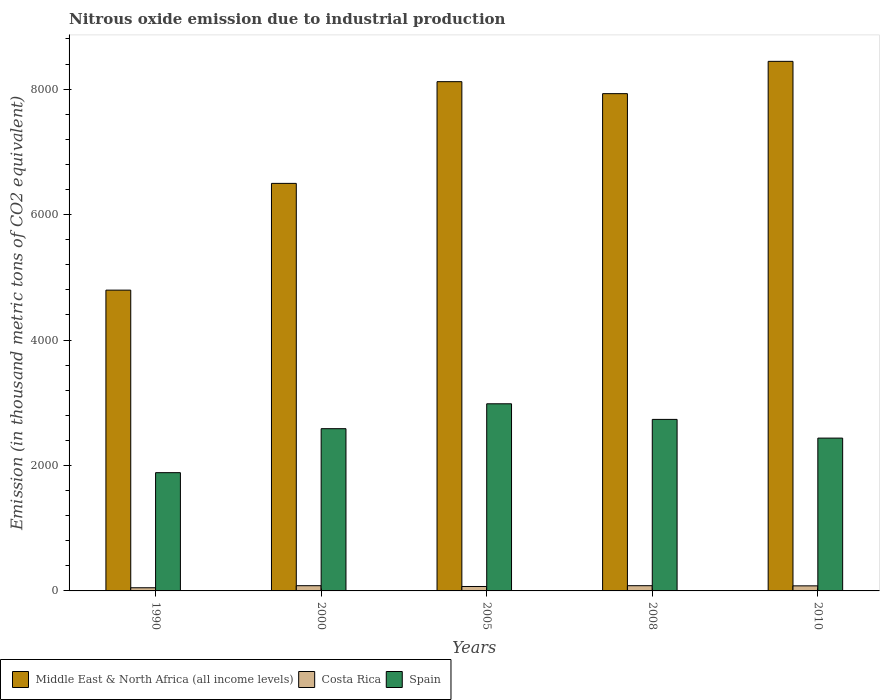How many groups of bars are there?
Your answer should be very brief. 5. Are the number of bars per tick equal to the number of legend labels?
Ensure brevity in your answer.  Yes. Are the number of bars on each tick of the X-axis equal?
Make the answer very short. Yes. How many bars are there on the 3rd tick from the right?
Provide a succinct answer. 3. What is the label of the 1st group of bars from the left?
Keep it short and to the point. 1990. In how many cases, is the number of bars for a given year not equal to the number of legend labels?
Offer a very short reply. 0. What is the amount of nitrous oxide emitted in Middle East & North Africa (all income levels) in 2010?
Your answer should be compact. 8442.5. Across all years, what is the maximum amount of nitrous oxide emitted in Costa Rica?
Your answer should be compact. 83.4. Across all years, what is the minimum amount of nitrous oxide emitted in Costa Rica?
Your answer should be compact. 50.5. In which year was the amount of nitrous oxide emitted in Spain maximum?
Make the answer very short. 2005. What is the total amount of nitrous oxide emitted in Middle East & North Africa (all income levels) in the graph?
Make the answer very short. 3.58e+04. What is the difference between the amount of nitrous oxide emitted in Costa Rica in 2000 and that in 2008?
Offer a terse response. 0. What is the difference between the amount of nitrous oxide emitted in Spain in 2010 and the amount of nitrous oxide emitted in Middle East & North Africa (all income levels) in 1990?
Your answer should be very brief. -2358.8. What is the average amount of nitrous oxide emitted in Middle East & North Africa (all income levels) per year?
Provide a succinct answer. 7156.2. In the year 2010, what is the difference between the amount of nitrous oxide emitted in Spain and amount of nitrous oxide emitted in Costa Rica?
Your answer should be very brief. 2355.6. In how many years, is the amount of nitrous oxide emitted in Middle East & North Africa (all income levels) greater than 4800 thousand metric tons?
Make the answer very short. 4. What is the ratio of the amount of nitrous oxide emitted in Spain in 2000 to that in 2010?
Offer a very short reply. 1.06. Is the difference between the amount of nitrous oxide emitted in Spain in 2000 and 2005 greater than the difference between the amount of nitrous oxide emitted in Costa Rica in 2000 and 2005?
Provide a short and direct response. No. What is the difference between the highest and the lowest amount of nitrous oxide emitted in Spain?
Offer a very short reply. 1098.1. In how many years, is the amount of nitrous oxide emitted in Spain greater than the average amount of nitrous oxide emitted in Spain taken over all years?
Provide a short and direct response. 3. What does the 2nd bar from the left in 2005 represents?
Provide a short and direct response. Costa Rica. What does the 1st bar from the right in 2010 represents?
Offer a very short reply. Spain. How many bars are there?
Your answer should be compact. 15. How many years are there in the graph?
Your answer should be very brief. 5. What is the difference between two consecutive major ticks on the Y-axis?
Offer a terse response. 2000. Does the graph contain grids?
Provide a short and direct response. No. How many legend labels are there?
Your response must be concise. 3. What is the title of the graph?
Ensure brevity in your answer.  Nitrous oxide emission due to industrial production. What is the label or title of the Y-axis?
Offer a terse response. Emission (in thousand metric tons of CO2 equivalent). What is the Emission (in thousand metric tons of CO2 equivalent) of Middle East & North Africa (all income levels) in 1990?
Your answer should be compact. 4795.2. What is the Emission (in thousand metric tons of CO2 equivalent) of Costa Rica in 1990?
Offer a terse response. 50.5. What is the Emission (in thousand metric tons of CO2 equivalent) in Spain in 1990?
Offer a terse response. 1885.3. What is the Emission (in thousand metric tons of CO2 equivalent) in Middle East & North Africa (all income levels) in 2000?
Offer a terse response. 6497. What is the Emission (in thousand metric tons of CO2 equivalent) in Costa Rica in 2000?
Offer a terse response. 83.4. What is the Emission (in thousand metric tons of CO2 equivalent) in Spain in 2000?
Your answer should be very brief. 2586.5. What is the Emission (in thousand metric tons of CO2 equivalent) of Middle East & North Africa (all income levels) in 2005?
Keep it short and to the point. 8118.6. What is the Emission (in thousand metric tons of CO2 equivalent) in Costa Rica in 2005?
Offer a very short reply. 70.7. What is the Emission (in thousand metric tons of CO2 equivalent) of Spain in 2005?
Offer a terse response. 2983.4. What is the Emission (in thousand metric tons of CO2 equivalent) in Middle East & North Africa (all income levels) in 2008?
Ensure brevity in your answer.  7927.7. What is the Emission (in thousand metric tons of CO2 equivalent) in Costa Rica in 2008?
Provide a short and direct response. 83.4. What is the Emission (in thousand metric tons of CO2 equivalent) in Spain in 2008?
Offer a very short reply. 2734.4. What is the Emission (in thousand metric tons of CO2 equivalent) of Middle East & North Africa (all income levels) in 2010?
Make the answer very short. 8442.5. What is the Emission (in thousand metric tons of CO2 equivalent) in Costa Rica in 2010?
Make the answer very short. 80.8. What is the Emission (in thousand metric tons of CO2 equivalent) in Spain in 2010?
Offer a very short reply. 2436.4. Across all years, what is the maximum Emission (in thousand metric tons of CO2 equivalent) in Middle East & North Africa (all income levels)?
Ensure brevity in your answer.  8442.5. Across all years, what is the maximum Emission (in thousand metric tons of CO2 equivalent) of Costa Rica?
Your response must be concise. 83.4. Across all years, what is the maximum Emission (in thousand metric tons of CO2 equivalent) of Spain?
Offer a very short reply. 2983.4. Across all years, what is the minimum Emission (in thousand metric tons of CO2 equivalent) of Middle East & North Africa (all income levels)?
Ensure brevity in your answer.  4795.2. Across all years, what is the minimum Emission (in thousand metric tons of CO2 equivalent) of Costa Rica?
Your answer should be very brief. 50.5. Across all years, what is the minimum Emission (in thousand metric tons of CO2 equivalent) of Spain?
Your response must be concise. 1885.3. What is the total Emission (in thousand metric tons of CO2 equivalent) in Middle East & North Africa (all income levels) in the graph?
Your answer should be compact. 3.58e+04. What is the total Emission (in thousand metric tons of CO2 equivalent) of Costa Rica in the graph?
Give a very brief answer. 368.8. What is the total Emission (in thousand metric tons of CO2 equivalent) in Spain in the graph?
Give a very brief answer. 1.26e+04. What is the difference between the Emission (in thousand metric tons of CO2 equivalent) in Middle East & North Africa (all income levels) in 1990 and that in 2000?
Keep it short and to the point. -1701.8. What is the difference between the Emission (in thousand metric tons of CO2 equivalent) of Costa Rica in 1990 and that in 2000?
Give a very brief answer. -32.9. What is the difference between the Emission (in thousand metric tons of CO2 equivalent) in Spain in 1990 and that in 2000?
Give a very brief answer. -701.2. What is the difference between the Emission (in thousand metric tons of CO2 equivalent) of Middle East & North Africa (all income levels) in 1990 and that in 2005?
Your answer should be compact. -3323.4. What is the difference between the Emission (in thousand metric tons of CO2 equivalent) in Costa Rica in 1990 and that in 2005?
Your response must be concise. -20.2. What is the difference between the Emission (in thousand metric tons of CO2 equivalent) in Spain in 1990 and that in 2005?
Provide a short and direct response. -1098.1. What is the difference between the Emission (in thousand metric tons of CO2 equivalent) in Middle East & North Africa (all income levels) in 1990 and that in 2008?
Your response must be concise. -3132.5. What is the difference between the Emission (in thousand metric tons of CO2 equivalent) in Costa Rica in 1990 and that in 2008?
Your answer should be compact. -32.9. What is the difference between the Emission (in thousand metric tons of CO2 equivalent) of Spain in 1990 and that in 2008?
Ensure brevity in your answer.  -849.1. What is the difference between the Emission (in thousand metric tons of CO2 equivalent) of Middle East & North Africa (all income levels) in 1990 and that in 2010?
Give a very brief answer. -3647.3. What is the difference between the Emission (in thousand metric tons of CO2 equivalent) of Costa Rica in 1990 and that in 2010?
Your answer should be compact. -30.3. What is the difference between the Emission (in thousand metric tons of CO2 equivalent) in Spain in 1990 and that in 2010?
Provide a succinct answer. -551.1. What is the difference between the Emission (in thousand metric tons of CO2 equivalent) of Middle East & North Africa (all income levels) in 2000 and that in 2005?
Offer a terse response. -1621.6. What is the difference between the Emission (in thousand metric tons of CO2 equivalent) of Costa Rica in 2000 and that in 2005?
Provide a succinct answer. 12.7. What is the difference between the Emission (in thousand metric tons of CO2 equivalent) in Spain in 2000 and that in 2005?
Ensure brevity in your answer.  -396.9. What is the difference between the Emission (in thousand metric tons of CO2 equivalent) in Middle East & North Africa (all income levels) in 2000 and that in 2008?
Keep it short and to the point. -1430.7. What is the difference between the Emission (in thousand metric tons of CO2 equivalent) of Spain in 2000 and that in 2008?
Offer a very short reply. -147.9. What is the difference between the Emission (in thousand metric tons of CO2 equivalent) of Middle East & North Africa (all income levels) in 2000 and that in 2010?
Provide a short and direct response. -1945.5. What is the difference between the Emission (in thousand metric tons of CO2 equivalent) in Costa Rica in 2000 and that in 2010?
Your answer should be very brief. 2.6. What is the difference between the Emission (in thousand metric tons of CO2 equivalent) in Spain in 2000 and that in 2010?
Your answer should be compact. 150.1. What is the difference between the Emission (in thousand metric tons of CO2 equivalent) of Middle East & North Africa (all income levels) in 2005 and that in 2008?
Keep it short and to the point. 190.9. What is the difference between the Emission (in thousand metric tons of CO2 equivalent) in Costa Rica in 2005 and that in 2008?
Provide a succinct answer. -12.7. What is the difference between the Emission (in thousand metric tons of CO2 equivalent) in Spain in 2005 and that in 2008?
Make the answer very short. 249. What is the difference between the Emission (in thousand metric tons of CO2 equivalent) of Middle East & North Africa (all income levels) in 2005 and that in 2010?
Make the answer very short. -323.9. What is the difference between the Emission (in thousand metric tons of CO2 equivalent) in Costa Rica in 2005 and that in 2010?
Make the answer very short. -10.1. What is the difference between the Emission (in thousand metric tons of CO2 equivalent) in Spain in 2005 and that in 2010?
Keep it short and to the point. 547. What is the difference between the Emission (in thousand metric tons of CO2 equivalent) in Middle East & North Africa (all income levels) in 2008 and that in 2010?
Provide a succinct answer. -514.8. What is the difference between the Emission (in thousand metric tons of CO2 equivalent) in Spain in 2008 and that in 2010?
Offer a very short reply. 298. What is the difference between the Emission (in thousand metric tons of CO2 equivalent) of Middle East & North Africa (all income levels) in 1990 and the Emission (in thousand metric tons of CO2 equivalent) of Costa Rica in 2000?
Your response must be concise. 4711.8. What is the difference between the Emission (in thousand metric tons of CO2 equivalent) of Middle East & North Africa (all income levels) in 1990 and the Emission (in thousand metric tons of CO2 equivalent) of Spain in 2000?
Provide a succinct answer. 2208.7. What is the difference between the Emission (in thousand metric tons of CO2 equivalent) in Costa Rica in 1990 and the Emission (in thousand metric tons of CO2 equivalent) in Spain in 2000?
Your answer should be compact. -2536. What is the difference between the Emission (in thousand metric tons of CO2 equivalent) of Middle East & North Africa (all income levels) in 1990 and the Emission (in thousand metric tons of CO2 equivalent) of Costa Rica in 2005?
Your response must be concise. 4724.5. What is the difference between the Emission (in thousand metric tons of CO2 equivalent) in Middle East & North Africa (all income levels) in 1990 and the Emission (in thousand metric tons of CO2 equivalent) in Spain in 2005?
Your response must be concise. 1811.8. What is the difference between the Emission (in thousand metric tons of CO2 equivalent) of Costa Rica in 1990 and the Emission (in thousand metric tons of CO2 equivalent) of Spain in 2005?
Provide a short and direct response. -2932.9. What is the difference between the Emission (in thousand metric tons of CO2 equivalent) of Middle East & North Africa (all income levels) in 1990 and the Emission (in thousand metric tons of CO2 equivalent) of Costa Rica in 2008?
Ensure brevity in your answer.  4711.8. What is the difference between the Emission (in thousand metric tons of CO2 equivalent) of Middle East & North Africa (all income levels) in 1990 and the Emission (in thousand metric tons of CO2 equivalent) of Spain in 2008?
Your answer should be very brief. 2060.8. What is the difference between the Emission (in thousand metric tons of CO2 equivalent) of Costa Rica in 1990 and the Emission (in thousand metric tons of CO2 equivalent) of Spain in 2008?
Your response must be concise. -2683.9. What is the difference between the Emission (in thousand metric tons of CO2 equivalent) in Middle East & North Africa (all income levels) in 1990 and the Emission (in thousand metric tons of CO2 equivalent) in Costa Rica in 2010?
Offer a very short reply. 4714.4. What is the difference between the Emission (in thousand metric tons of CO2 equivalent) of Middle East & North Africa (all income levels) in 1990 and the Emission (in thousand metric tons of CO2 equivalent) of Spain in 2010?
Offer a terse response. 2358.8. What is the difference between the Emission (in thousand metric tons of CO2 equivalent) in Costa Rica in 1990 and the Emission (in thousand metric tons of CO2 equivalent) in Spain in 2010?
Provide a short and direct response. -2385.9. What is the difference between the Emission (in thousand metric tons of CO2 equivalent) in Middle East & North Africa (all income levels) in 2000 and the Emission (in thousand metric tons of CO2 equivalent) in Costa Rica in 2005?
Ensure brevity in your answer.  6426.3. What is the difference between the Emission (in thousand metric tons of CO2 equivalent) of Middle East & North Africa (all income levels) in 2000 and the Emission (in thousand metric tons of CO2 equivalent) of Spain in 2005?
Provide a succinct answer. 3513.6. What is the difference between the Emission (in thousand metric tons of CO2 equivalent) in Costa Rica in 2000 and the Emission (in thousand metric tons of CO2 equivalent) in Spain in 2005?
Keep it short and to the point. -2900. What is the difference between the Emission (in thousand metric tons of CO2 equivalent) in Middle East & North Africa (all income levels) in 2000 and the Emission (in thousand metric tons of CO2 equivalent) in Costa Rica in 2008?
Offer a terse response. 6413.6. What is the difference between the Emission (in thousand metric tons of CO2 equivalent) in Middle East & North Africa (all income levels) in 2000 and the Emission (in thousand metric tons of CO2 equivalent) in Spain in 2008?
Provide a succinct answer. 3762.6. What is the difference between the Emission (in thousand metric tons of CO2 equivalent) in Costa Rica in 2000 and the Emission (in thousand metric tons of CO2 equivalent) in Spain in 2008?
Your answer should be very brief. -2651. What is the difference between the Emission (in thousand metric tons of CO2 equivalent) in Middle East & North Africa (all income levels) in 2000 and the Emission (in thousand metric tons of CO2 equivalent) in Costa Rica in 2010?
Your answer should be very brief. 6416.2. What is the difference between the Emission (in thousand metric tons of CO2 equivalent) of Middle East & North Africa (all income levels) in 2000 and the Emission (in thousand metric tons of CO2 equivalent) of Spain in 2010?
Provide a short and direct response. 4060.6. What is the difference between the Emission (in thousand metric tons of CO2 equivalent) in Costa Rica in 2000 and the Emission (in thousand metric tons of CO2 equivalent) in Spain in 2010?
Ensure brevity in your answer.  -2353. What is the difference between the Emission (in thousand metric tons of CO2 equivalent) in Middle East & North Africa (all income levels) in 2005 and the Emission (in thousand metric tons of CO2 equivalent) in Costa Rica in 2008?
Offer a terse response. 8035.2. What is the difference between the Emission (in thousand metric tons of CO2 equivalent) in Middle East & North Africa (all income levels) in 2005 and the Emission (in thousand metric tons of CO2 equivalent) in Spain in 2008?
Offer a terse response. 5384.2. What is the difference between the Emission (in thousand metric tons of CO2 equivalent) of Costa Rica in 2005 and the Emission (in thousand metric tons of CO2 equivalent) of Spain in 2008?
Provide a short and direct response. -2663.7. What is the difference between the Emission (in thousand metric tons of CO2 equivalent) in Middle East & North Africa (all income levels) in 2005 and the Emission (in thousand metric tons of CO2 equivalent) in Costa Rica in 2010?
Provide a short and direct response. 8037.8. What is the difference between the Emission (in thousand metric tons of CO2 equivalent) of Middle East & North Africa (all income levels) in 2005 and the Emission (in thousand metric tons of CO2 equivalent) of Spain in 2010?
Provide a short and direct response. 5682.2. What is the difference between the Emission (in thousand metric tons of CO2 equivalent) in Costa Rica in 2005 and the Emission (in thousand metric tons of CO2 equivalent) in Spain in 2010?
Offer a very short reply. -2365.7. What is the difference between the Emission (in thousand metric tons of CO2 equivalent) in Middle East & North Africa (all income levels) in 2008 and the Emission (in thousand metric tons of CO2 equivalent) in Costa Rica in 2010?
Offer a very short reply. 7846.9. What is the difference between the Emission (in thousand metric tons of CO2 equivalent) in Middle East & North Africa (all income levels) in 2008 and the Emission (in thousand metric tons of CO2 equivalent) in Spain in 2010?
Offer a very short reply. 5491.3. What is the difference between the Emission (in thousand metric tons of CO2 equivalent) of Costa Rica in 2008 and the Emission (in thousand metric tons of CO2 equivalent) of Spain in 2010?
Offer a very short reply. -2353. What is the average Emission (in thousand metric tons of CO2 equivalent) of Middle East & North Africa (all income levels) per year?
Your answer should be compact. 7156.2. What is the average Emission (in thousand metric tons of CO2 equivalent) in Costa Rica per year?
Keep it short and to the point. 73.76. What is the average Emission (in thousand metric tons of CO2 equivalent) of Spain per year?
Give a very brief answer. 2525.2. In the year 1990, what is the difference between the Emission (in thousand metric tons of CO2 equivalent) of Middle East & North Africa (all income levels) and Emission (in thousand metric tons of CO2 equivalent) of Costa Rica?
Offer a very short reply. 4744.7. In the year 1990, what is the difference between the Emission (in thousand metric tons of CO2 equivalent) in Middle East & North Africa (all income levels) and Emission (in thousand metric tons of CO2 equivalent) in Spain?
Keep it short and to the point. 2909.9. In the year 1990, what is the difference between the Emission (in thousand metric tons of CO2 equivalent) of Costa Rica and Emission (in thousand metric tons of CO2 equivalent) of Spain?
Make the answer very short. -1834.8. In the year 2000, what is the difference between the Emission (in thousand metric tons of CO2 equivalent) in Middle East & North Africa (all income levels) and Emission (in thousand metric tons of CO2 equivalent) in Costa Rica?
Provide a succinct answer. 6413.6. In the year 2000, what is the difference between the Emission (in thousand metric tons of CO2 equivalent) in Middle East & North Africa (all income levels) and Emission (in thousand metric tons of CO2 equivalent) in Spain?
Your response must be concise. 3910.5. In the year 2000, what is the difference between the Emission (in thousand metric tons of CO2 equivalent) of Costa Rica and Emission (in thousand metric tons of CO2 equivalent) of Spain?
Give a very brief answer. -2503.1. In the year 2005, what is the difference between the Emission (in thousand metric tons of CO2 equivalent) in Middle East & North Africa (all income levels) and Emission (in thousand metric tons of CO2 equivalent) in Costa Rica?
Keep it short and to the point. 8047.9. In the year 2005, what is the difference between the Emission (in thousand metric tons of CO2 equivalent) of Middle East & North Africa (all income levels) and Emission (in thousand metric tons of CO2 equivalent) of Spain?
Your response must be concise. 5135.2. In the year 2005, what is the difference between the Emission (in thousand metric tons of CO2 equivalent) of Costa Rica and Emission (in thousand metric tons of CO2 equivalent) of Spain?
Offer a very short reply. -2912.7. In the year 2008, what is the difference between the Emission (in thousand metric tons of CO2 equivalent) in Middle East & North Africa (all income levels) and Emission (in thousand metric tons of CO2 equivalent) in Costa Rica?
Ensure brevity in your answer.  7844.3. In the year 2008, what is the difference between the Emission (in thousand metric tons of CO2 equivalent) in Middle East & North Africa (all income levels) and Emission (in thousand metric tons of CO2 equivalent) in Spain?
Provide a succinct answer. 5193.3. In the year 2008, what is the difference between the Emission (in thousand metric tons of CO2 equivalent) in Costa Rica and Emission (in thousand metric tons of CO2 equivalent) in Spain?
Give a very brief answer. -2651. In the year 2010, what is the difference between the Emission (in thousand metric tons of CO2 equivalent) of Middle East & North Africa (all income levels) and Emission (in thousand metric tons of CO2 equivalent) of Costa Rica?
Provide a succinct answer. 8361.7. In the year 2010, what is the difference between the Emission (in thousand metric tons of CO2 equivalent) of Middle East & North Africa (all income levels) and Emission (in thousand metric tons of CO2 equivalent) of Spain?
Your answer should be very brief. 6006.1. In the year 2010, what is the difference between the Emission (in thousand metric tons of CO2 equivalent) in Costa Rica and Emission (in thousand metric tons of CO2 equivalent) in Spain?
Make the answer very short. -2355.6. What is the ratio of the Emission (in thousand metric tons of CO2 equivalent) in Middle East & North Africa (all income levels) in 1990 to that in 2000?
Provide a succinct answer. 0.74. What is the ratio of the Emission (in thousand metric tons of CO2 equivalent) of Costa Rica in 1990 to that in 2000?
Keep it short and to the point. 0.61. What is the ratio of the Emission (in thousand metric tons of CO2 equivalent) in Spain in 1990 to that in 2000?
Give a very brief answer. 0.73. What is the ratio of the Emission (in thousand metric tons of CO2 equivalent) of Middle East & North Africa (all income levels) in 1990 to that in 2005?
Your answer should be very brief. 0.59. What is the ratio of the Emission (in thousand metric tons of CO2 equivalent) of Costa Rica in 1990 to that in 2005?
Offer a very short reply. 0.71. What is the ratio of the Emission (in thousand metric tons of CO2 equivalent) in Spain in 1990 to that in 2005?
Provide a succinct answer. 0.63. What is the ratio of the Emission (in thousand metric tons of CO2 equivalent) in Middle East & North Africa (all income levels) in 1990 to that in 2008?
Make the answer very short. 0.6. What is the ratio of the Emission (in thousand metric tons of CO2 equivalent) of Costa Rica in 1990 to that in 2008?
Give a very brief answer. 0.61. What is the ratio of the Emission (in thousand metric tons of CO2 equivalent) of Spain in 1990 to that in 2008?
Offer a very short reply. 0.69. What is the ratio of the Emission (in thousand metric tons of CO2 equivalent) in Middle East & North Africa (all income levels) in 1990 to that in 2010?
Your answer should be very brief. 0.57. What is the ratio of the Emission (in thousand metric tons of CO2 equivalent) in Costa Rica in 1990 to that in 2010?
Your answer should be compact. 0.62. What is the ratio of the Emission (in thousand metric tons of CO2 equivalent) of Spain in 1990 to that in 2010?
Offer a terse response. 0.77. What is the ratio of the Emission (in thousand metric tons of CO2 equivalent) in Middle East & North Africa (all income levels) in 2000 to that in 2005?
Provide a succinct answer. 0.8. What is the ratio of the Emission (in thousand metric tons of CO2 equivalent) in Costa Rica in 2000 to that in 2005?
Give a very brief answer. 1.18. What is the ratio of the Emission (in thousand metric tons of CO2 equivalent) in Spain in 2000 to that in 2005?
Offer a terse response. 0.87. What is the ratio of the Emission (in thousand metric tons of CO2 equivalent) in Middle East & North Africa (all income levels) in 2000 to that in 2008?
Provide a short and direct response. 0.82. What is the ratio of the Emission (in thousand metric tons of CO2 equivalent) of Costa Rica in 2000 to that in 2008?
Ensure brevity in your answer.  1. What is the ratio of the Emission (in thousand metric tons of CO2 equivalent) of Spain in 2000 to that in 2008?
Offer a very short reply. 0.95. What is the ratio of the Emission (in thousand metric tons of CO2 equivalent) of Middle East & North Africa (all income levels) in 2000 to that in 2010?
Your answer should be compact. 0.77. What is the ratio of the Emission (in thousand metric tons of CO2 equivalent) in Costa Rica in 2000 to that in 2010?
Your answer should be very brief. 1.03. What is the ratio of the Emission (in thousand metric tons of CO2 equivalent) in Spain in 2000 to that in 2010?
Make the answer very short. 1.06. What is the ratio of the Emission (in thousand metric tons of CO2 equivalent) of Middle East & North Africa (all income levels) in 2005 to that in 2008?
Ensure brevity in your answer.  1.02. What is the ratio of the Emission (in thousand metric tons of CO2 equivalent) in Costa Rica in 2005 to that in 2008?
Give a very brief answer. 0.85. What is the ratio of the Emission (in thousand metric tons of CO2 equivalent) in Spain in 2005 to that in 2008?
Your response must be concise. 1.09. What is the ratio of the Emission (in thousand metric tons of CO2 equivalent) in Middle East & North Africa (all income levels) in 2005 to that in 2010?
Offer a terse response. 0.96. What is the ratio of the Emission (in thousand metric tons of CO2 equivalent) of Spain in 2005 to that in 2010?
Ensure brevity in your answer.  1.22. What is the ratio of the Emission (in thousand metric tons of CO2 equivalent) of Middle East & North Africa (all income levels) in 2008 to that in 2010?
Your answer should be compact. 0.94. What is the ratio of the Emission (in thousand metric tons of CO2 equivalent) of Costa Rica in 2008 to that in 2010?
Ensure brevity in your answer.  1.03. What is the ratio of the Emission (in thousand metric tons of CO2 equivalent) of Spain in 2008 to that in 2010?
Offer a very short reply. 1.12. What is the difference between the highest and the second highest Emission (in thousand metric tons of CO2 equivalent) of Middle East & North Africa (all income levels)?
Keep it short and to the point. 323.9. What is the difference between the highest and the second highest Emission (in thousand metric tons of CO2 equivalent) in Costa Rica?
Keep it short and to the point. 0. What is the difference between the highest and the second highest Emission (in thousand metric tons of CO2 equivalent) of Spain?
Give a very brief answer. 249. What is the difference between the highest and the lowest Emission (in thousand metric tons of CO2 equivalent) in Middle East & North Africa (all income levels)?
Provide a succinct answer. 3647.3. What is the difference between the highest and the lowest Emission (in thousand metric tons of CO2 equivalent) in Costa Rica?
Your answer should be very brief. 32.9. What is the difference between the highest and the lowest Emission (in thousand metric tons of CO2 equivalent) of Spain?
Make the answer very short. 1098.1. 